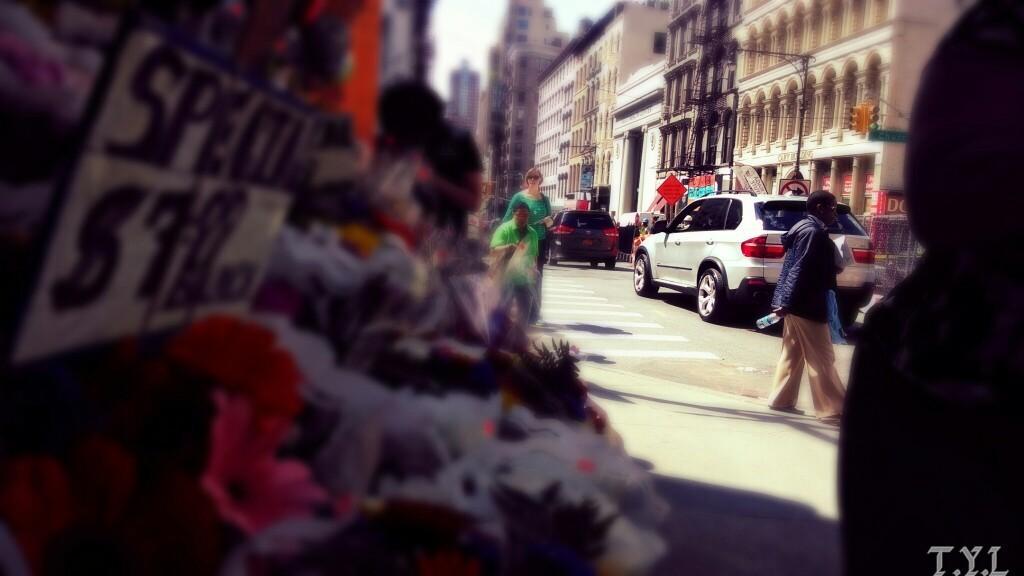Please provide a concise description of this image. In this image we can see road. To the right side of the road cars are there and buildings are present. And few people are walking on the road. Left side of the image bouquet shop is there. 